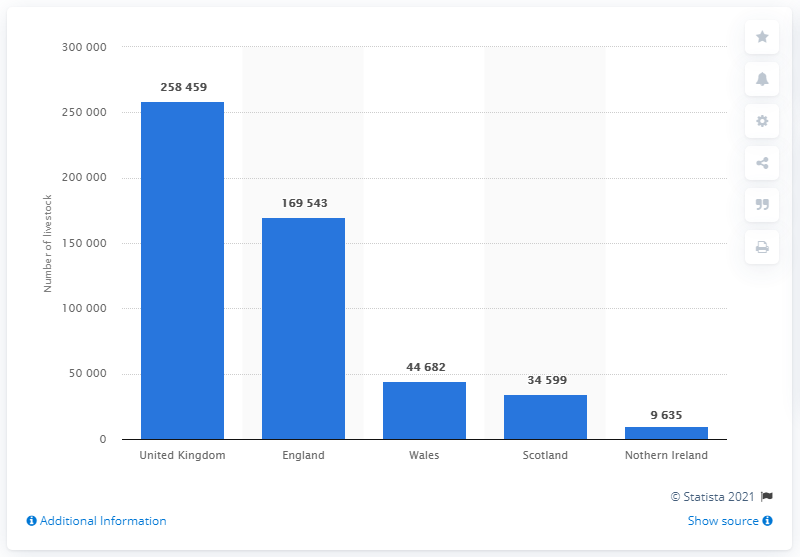Specify some key components in this picture. As of June 2017, there were 169,543 horses in England. As of June 2017, there were approximately 169,543 horses owned in Scotland. 